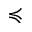<formula> <loc_0><loc_0><loc_500><loc_500>\prec c u r l y e q</formula> 